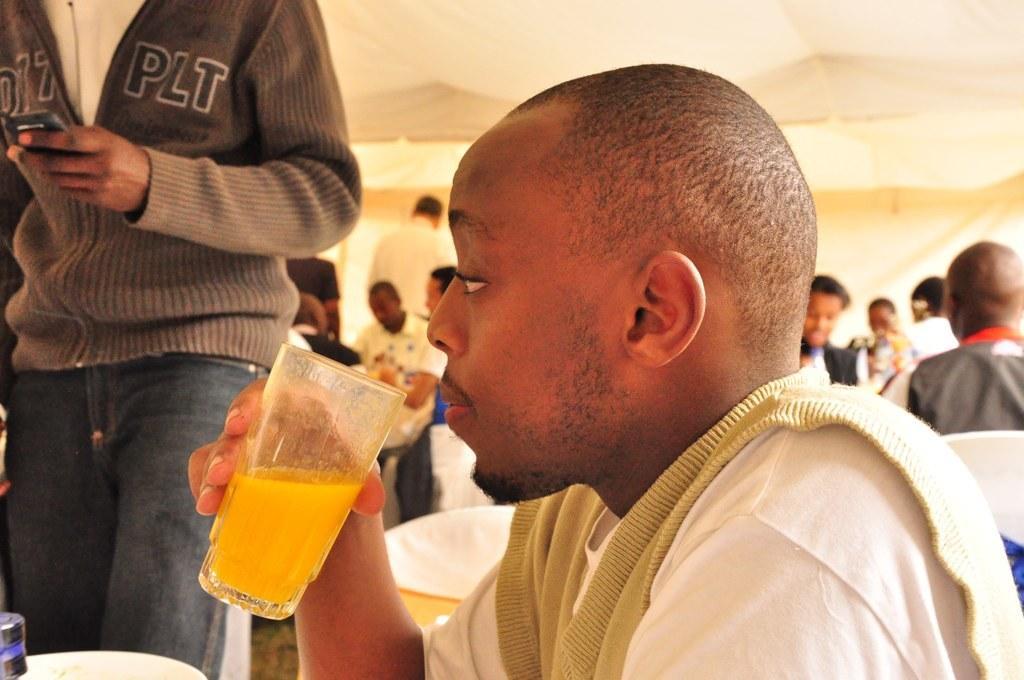In one or two sentences, can you explain what this image depicts? In this image we can see people sitting on the chairs and some are standing on the floor. Of them one is holding a beverage tumbler in the hand. 